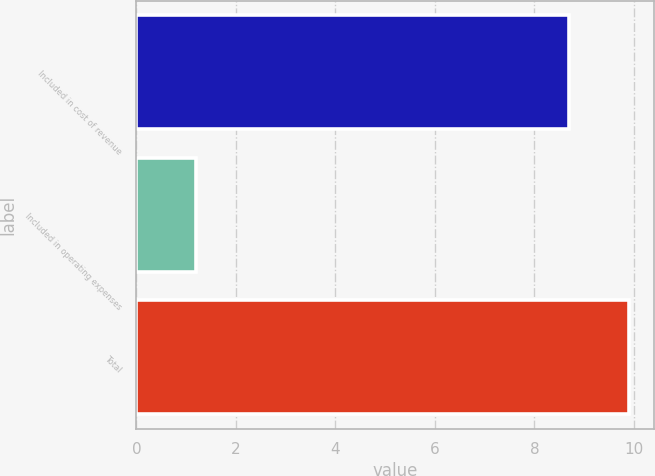Convert chart. <chart><loc_0><loc_0><loc_500><loc_500><bar_chart><fcel>Included in cost of revenue<fcel>Included in operating expenses<fcel>Total<nl><fcel>8.7<fcel>1.2<fcel>9.9<nl></chart> 